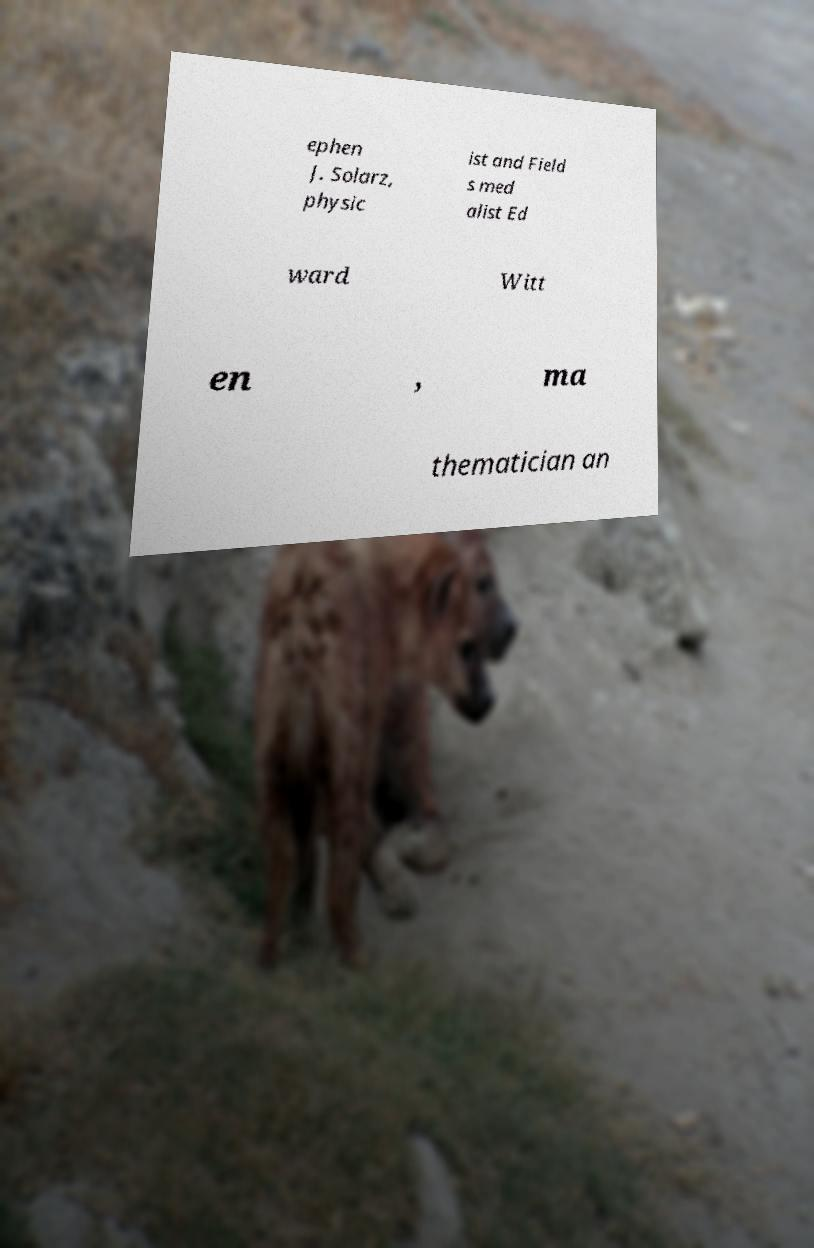For documentation purposes, I need the text within this image transcribed. Could you provide that? ephen J. Solarz, physic ist and Field s med alist Ed ward Witt en , ma thematician an 